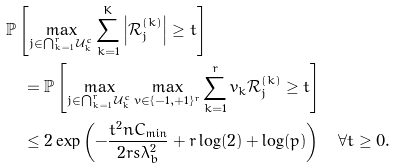<formula> <loc_0><loc_0><loc_500><loc_500>& \mathbb { P } \left [ \max _ { j \in \bigcap _ { k = 1 } ^ { r } \mathcal { U } _ { k } ^ { c } } \sum _ { k = 1 } ^ { K } \left | \mathcal { R } _ { j } ^ { ( k ) } \right | \geq t \right ] \\ & \quad = \mathbb { P } \left [ \max _ { j \in \bigcap _ { k = 1 } ^ { r } \mathcal { U } _ { k } ^ { c } } \max _ { v \in \{ - 1 , + 1 \} ^ { r } } \sum _ { k = 1 } ^ { r } v _ { k } \mathcal { R } _ { j } ^ { ( k ) } \geq t \right ] \\ & \quad \leq 2 \exp \left ( - \frac { t ^ { 2 } n C _ { \min } } { 2 r s \lambda _ { b } ^ { 2 } } + r \log ( 2 ) + \log ( p ) \right ) \quad \forall t \geq 0 . \\</formula> 